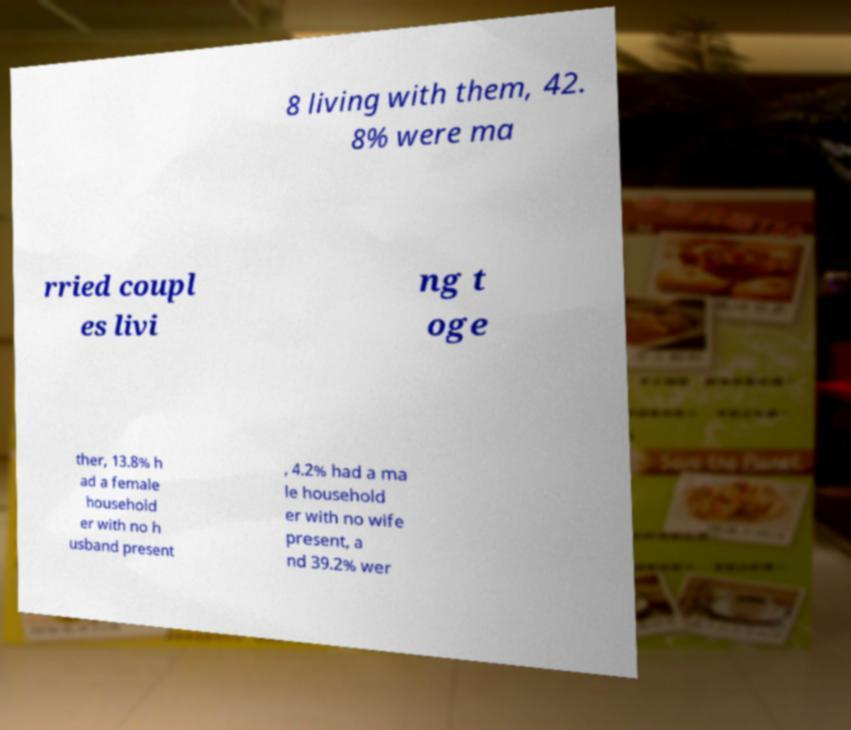I need the written content from this picture converted into text. Can you do that? 8 living with them, 42. 8% were ma rried coupl es livi ng t oge ther, 13.8% h ad a female household er with no h usband present , 4.2% had a ma le household er with no wife present, a nd 39.2% wer 